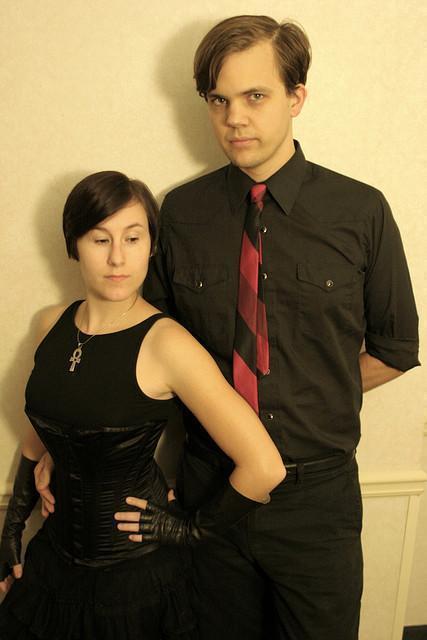What's the name of the pendant on the woman's necklace?
Make your selection and explain in format: 'Answer: answer
Rationale: rationale.'
Options: Dagger, ankh, staff, cross. Answer: ankh.
Rationale: The pendant is an ankh. 